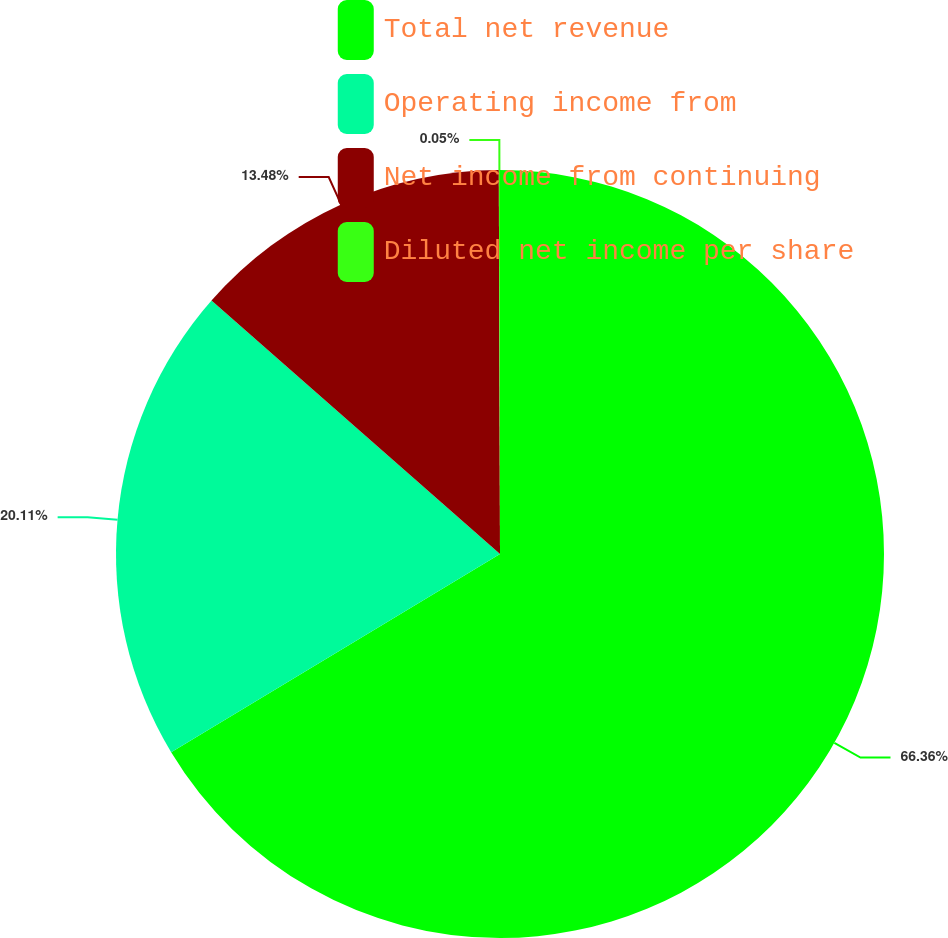Convert chart. <chart><loc_0><loc_0><loc_500><loc_500><pie_chart><fcel>Total net revenue<fcel>Operating income from<fcel>Net income from continuing<fcel>Diluted net income per share<nl><fcel>66.37%<fcel>20.11%<fcel>13.48%<fcel>0.05%<nl></chart> 